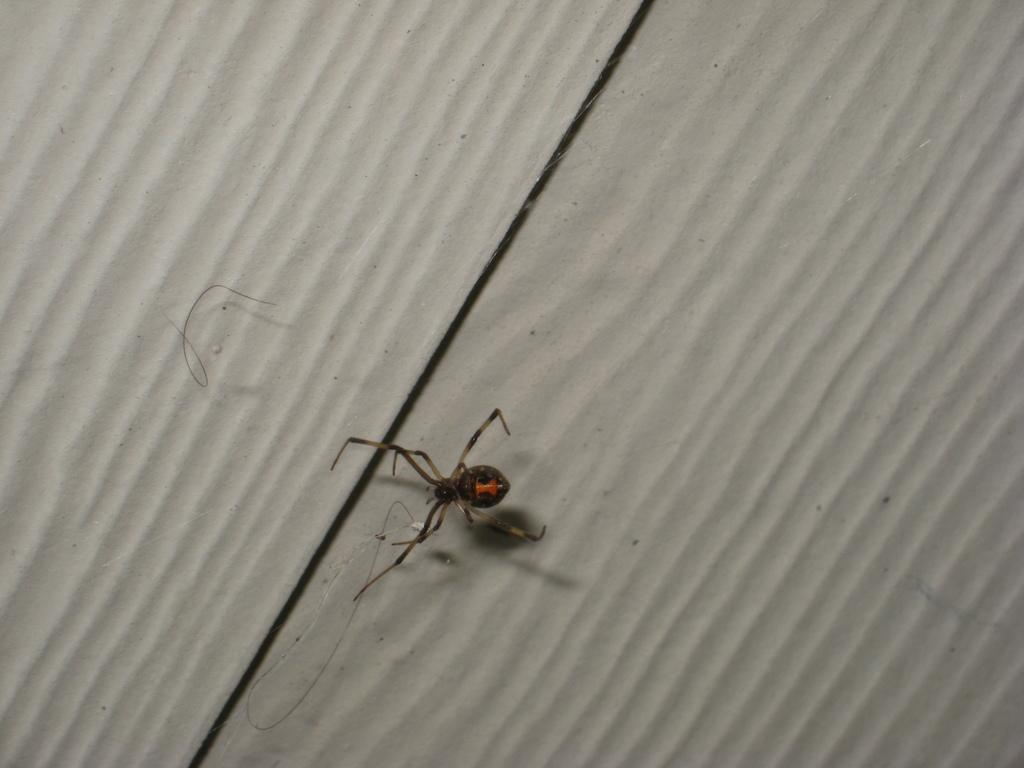What type of creature is in the picture? There is an insect in the picture. Can you describe the colors of the insect? The insect has black, cream, and orange colors. What is located at the bottom of the image? There appears to be a wall at the bottom of the image. What type of chair is visible in the image? There is no chair present in the image. What shape does the insect have in the image? The provided facts do not mention the shape of the insect, so we cannot determine its shape from the image. 